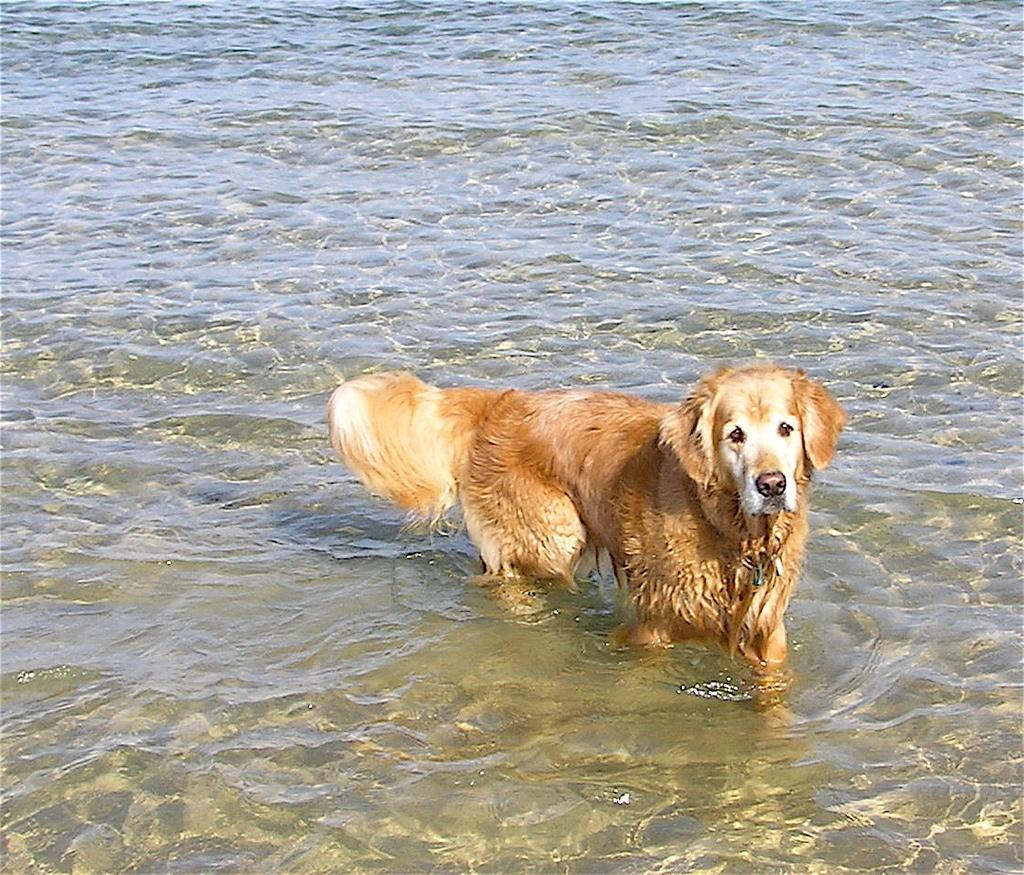What animal is present in the image? There is a dog in the image. Where is the dog located in the image? The dog is standing in the water. What type of brick is the dog carrying in the image? There is no brick present in the image; the dog is standing in the water. 